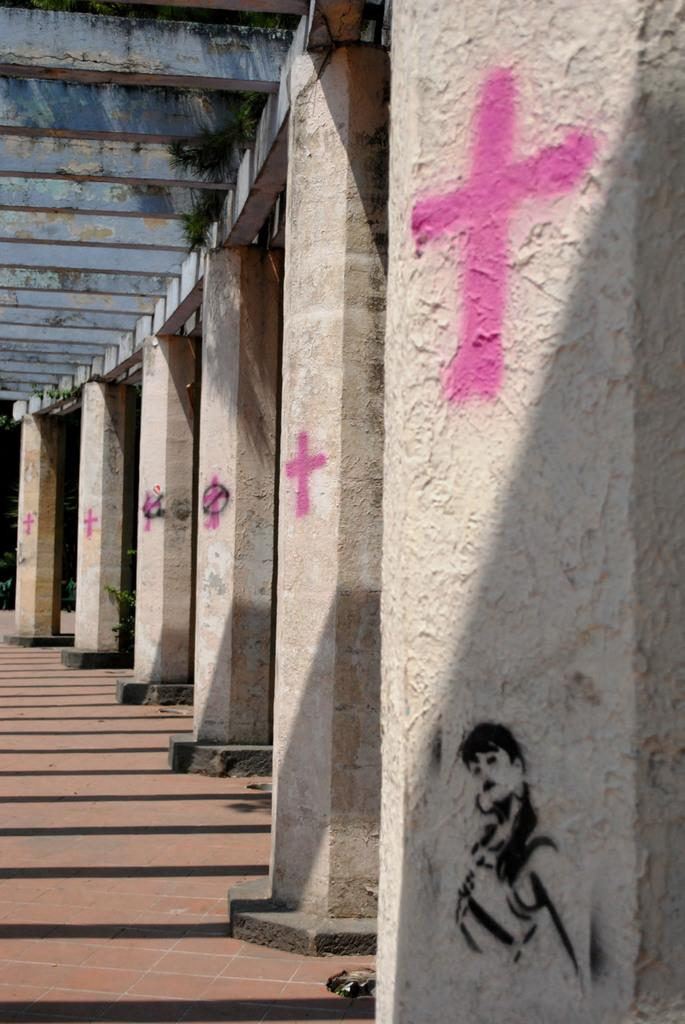What architectural features can be seen on the right side of the image? There are pillars on the right side of the image. What type of flooring is visible at the bottom of the image? There are tiles at the bottom of the image. What religious symbols are present on the pillars? Christianity symbols are present on the pillars. What color of mitten is being used to paint the border in the image? There is no mitten or painting activity present in the image. 